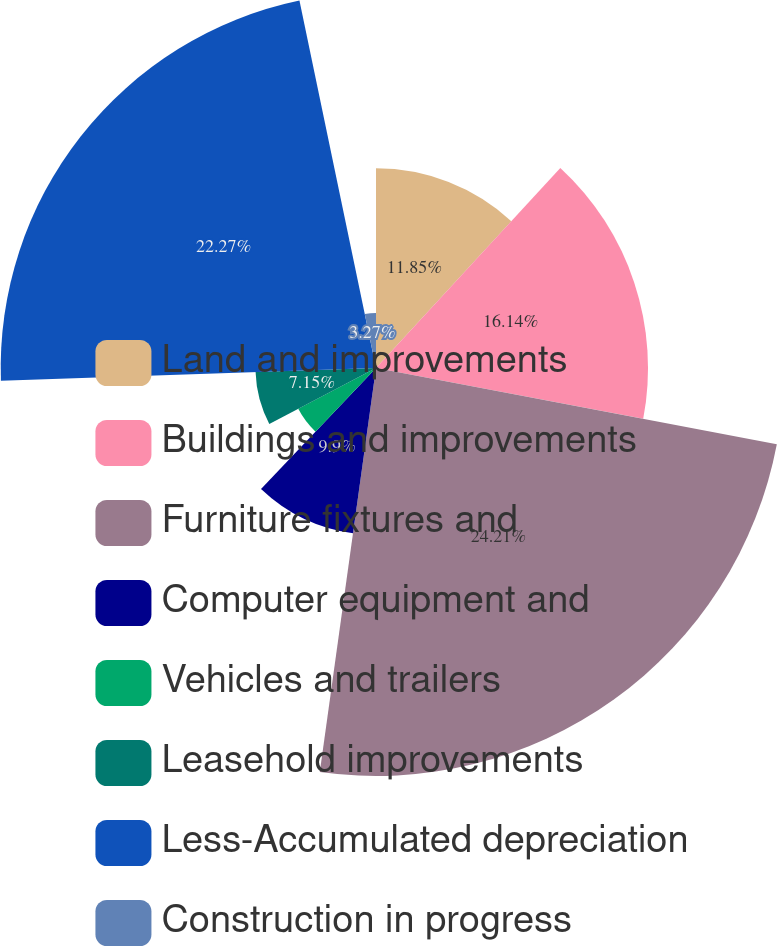Convert chart to OTSL. <chart><loc_0><loc_0><loc_500><loc_500><pie_chart><fcel>Land and improvements<fcel>Buildings and improvements<fcel>Furniture fixtures and<fcel>Computer equipment and<fcel>Vehicles and trailers<fcel>Leasehold improvements<fcel>Less-Accumulated depreciation<fcel>Construction in progress<nl><fcel>11.85%<fcel>16.14%<fcel>24.21%<fcel>9.9%<fcel>5.21%<fcel>7.15%<fcel>22.27%<fcel>3.27%<nl></chart> 